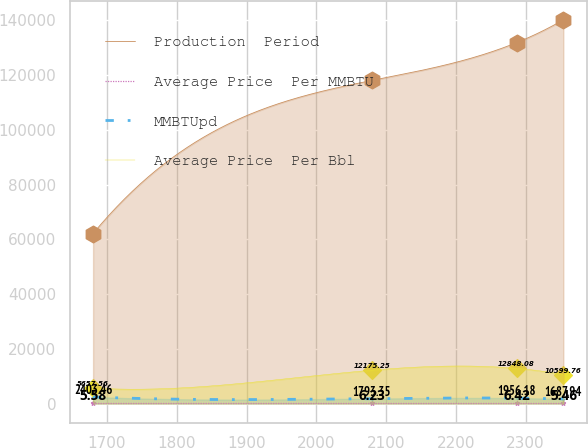<chart> <loc_0><loc_0><loc_500><loc_500><line_chart><ecel><fcel>Production  Period<fcel>Average Price  Per MMBTU<fcel>MMBTUpd<fcel>Average Price  Per Bbl<nl><fcel>1680.01<fcel>62138.2<fcel>5.58<fcel>2403.46<fcel>5657.56<nl><fcel>2079.45<fcel>118070<fcel>6.23<fcel>1793.35<fcel>12175.2<nl><fcel>2287.07<fcel>131910<fcel>6.42<fcel>1956.18<fcel>12848.1<nl><fcel>2354.09<fcel>140236<fcel>5.46<fcel>1687.94<fcel>10599.8<nl></chart> 